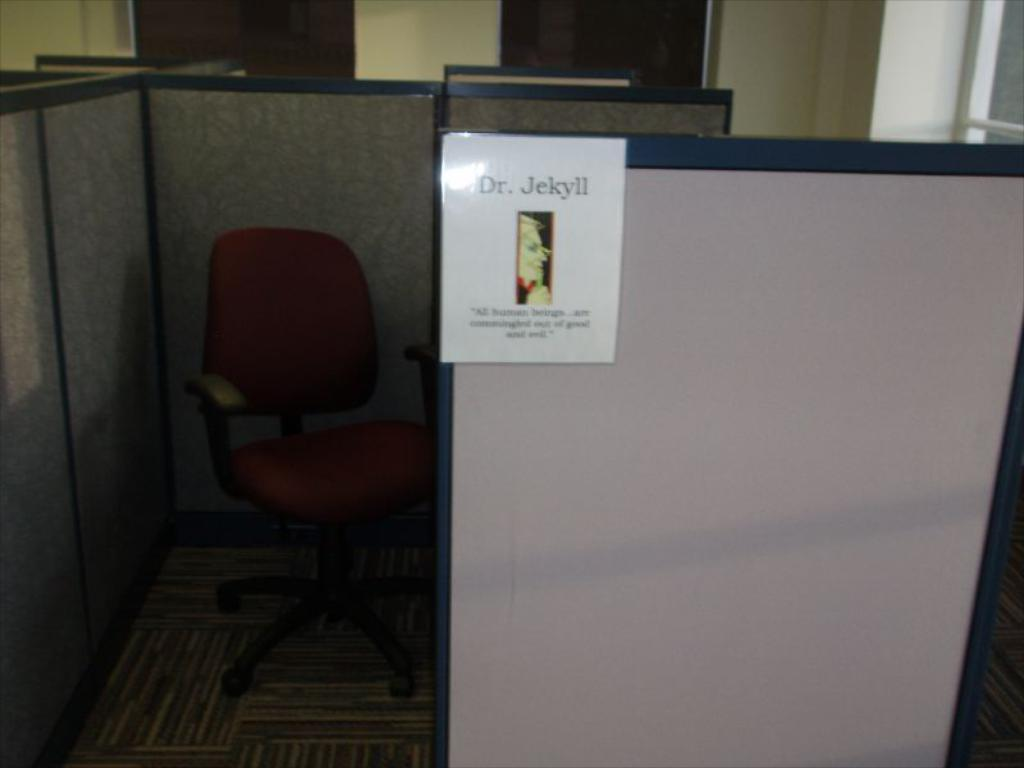<image>
Write a terse but informative summary of the picture. An office cubicle with a picture of Dr. Jekyll on the side of the wall. 